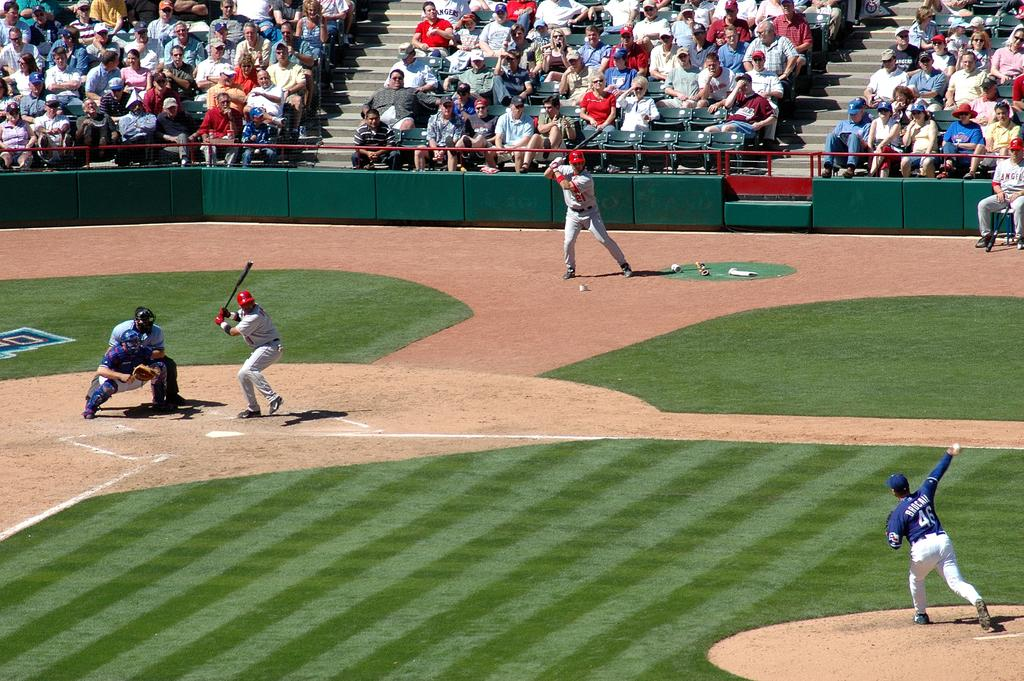What is the main setting of the image? There is a ground in the image. What are the people on the ground doing? The people on the ground are playing a game. What are the people in the background doing? The people in the background are sitting on chairs and watching the game. What type of record is being played by the coach in the image? There is no record or coach present in the image. 